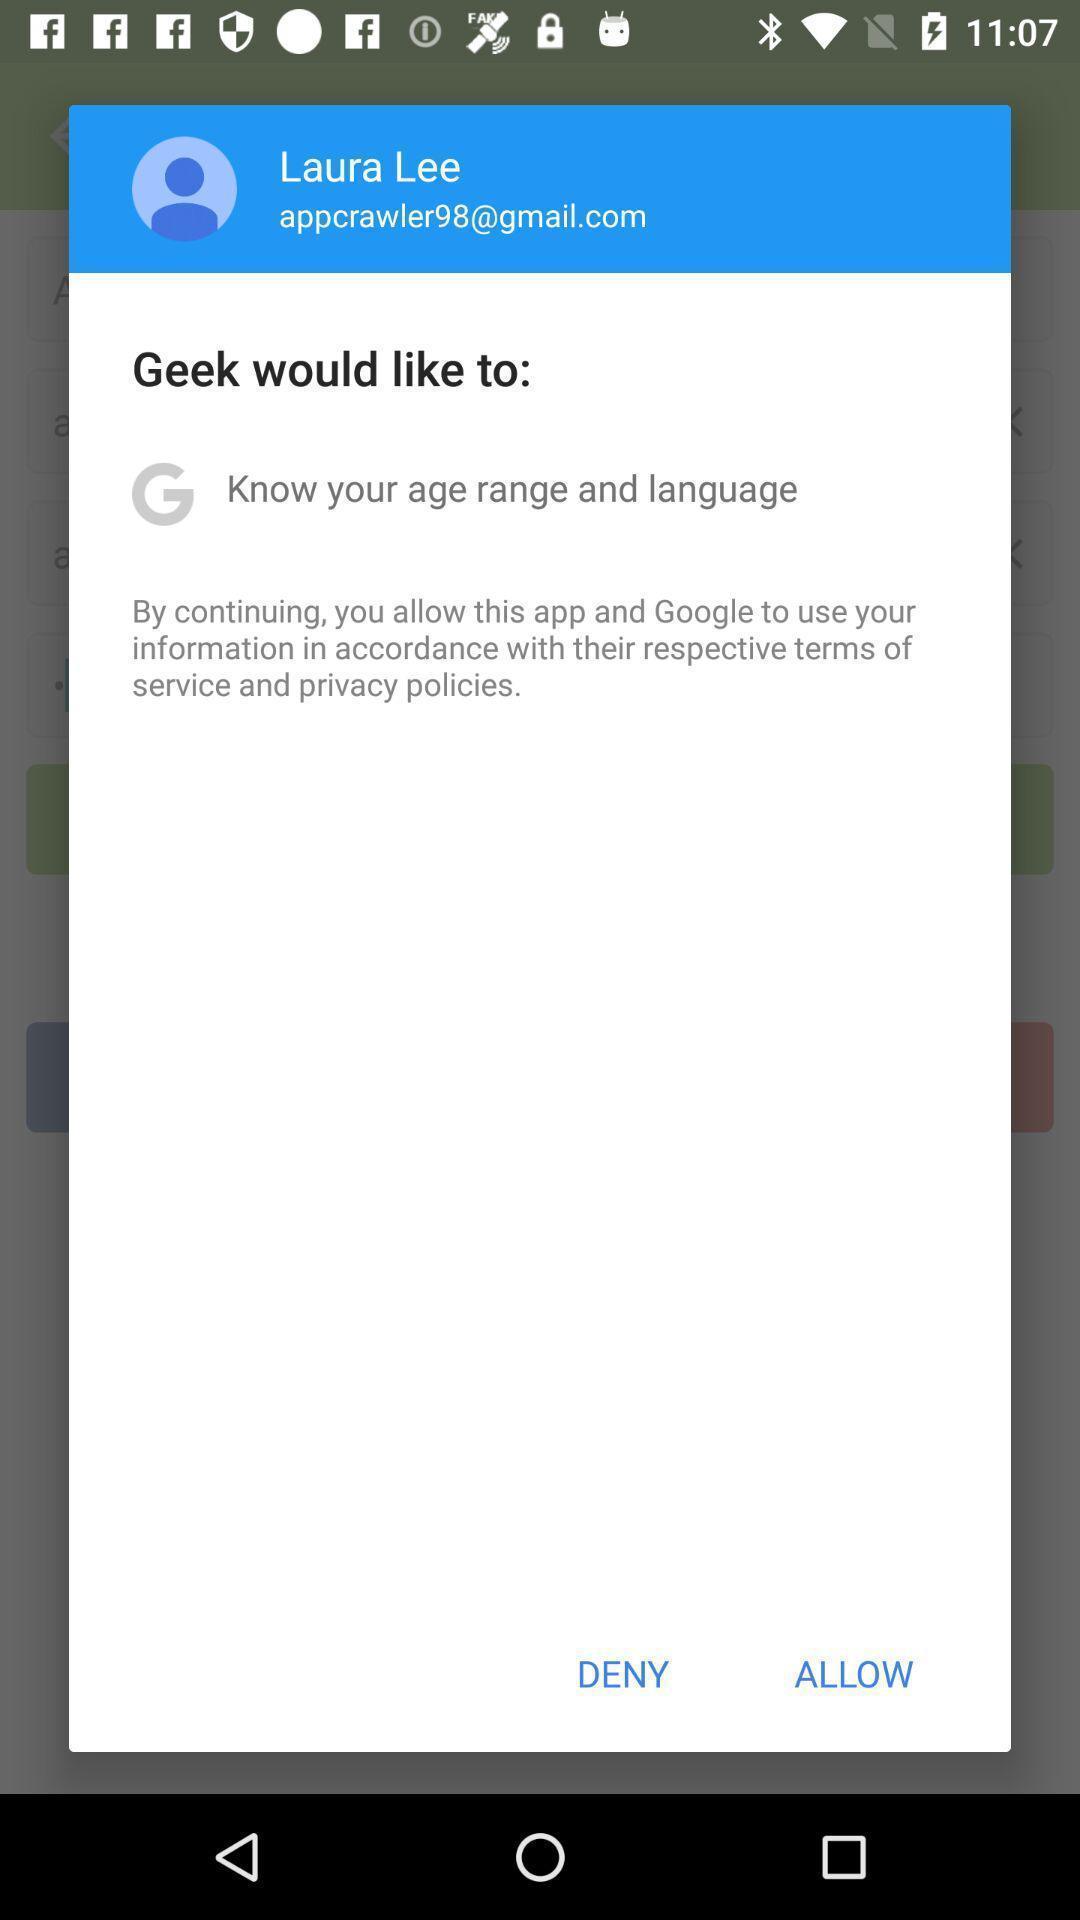Describe the visual elements of this screenshot. Pop-up shows to continue with an application. 